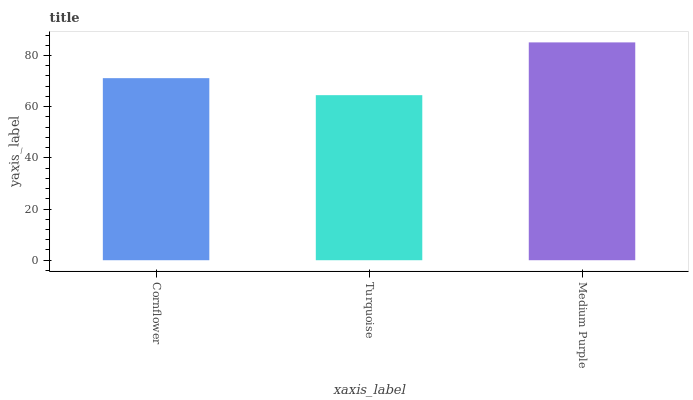Is Turquoise the minimum?
Answer yes or no. Yes. Is Medium Purple the maximum?
Answer yes or no. Yes. Is Medium Purple the minimum?
Answer yes or no. No. Is Turquoise the maximum?
Answer yes or no. No. Is Medium Purple greater than Turquoise?
Answer yes or no. Yes. Is Turquoise less than Medium Purple?
Answer yes or no. Yes. Is Turquoise greater than Medium Purple?
Answer yes or no. No. Is Medium Purple less than Turquoise?
Answer yes or no. No. Is Cornflower the high median?
Answer yes or no. Yes. Is Cornflower the low median?
Answer yes or no. Yes. Is Medium Purple the high median?
Answer yes or no. No. Is Medium Purple the low median?
Answer yes or no. No. 